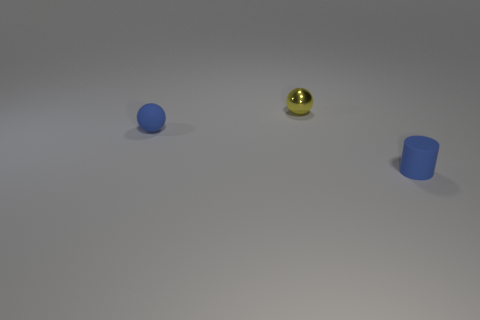There is a small blue object in front of the small sphere on the left side of the metal thing; how many yellow things are behind it?
Ensure brevity in your answer.  1. How many yellow metal objects are in front of the tiny blue cylinder?
Ensure brevity in your answer.  0. What is the color of the small thing that is left of the small ball that is right of the tiny blue sphere?
Your answer should be very brief. Blue. How many other objects are the same material as the cylinder?
Offer a very short reply. 1. Is the number of small rubber things that are in front of the blue rubber cylinder the same as the number of big red cubes?
Ensure brevity in your answer.  Yes. There is a yellow object that is behind the rubber object in front of the blue object to the left of the cylinder; what is its material?
Make the answer very short. Metal. The tiny rubber object to the left of the tiny matte cylinder is what color?
Your answer should be compact. Blue. How big is the matte cylinder that is in front of the small blue matte object that is behind the blue cylinder?
Make the answer very short. Small. Is the number of blue cylinders that are in front of the yellow sphere the same as the number of tiny matte spheres behind the blue matte cylinder?
Give a very brief answer. Yes. There is a tiny cylinder that is made of the same material as the blue ball; what is its color?
Provide a succinct answer. Blue. 